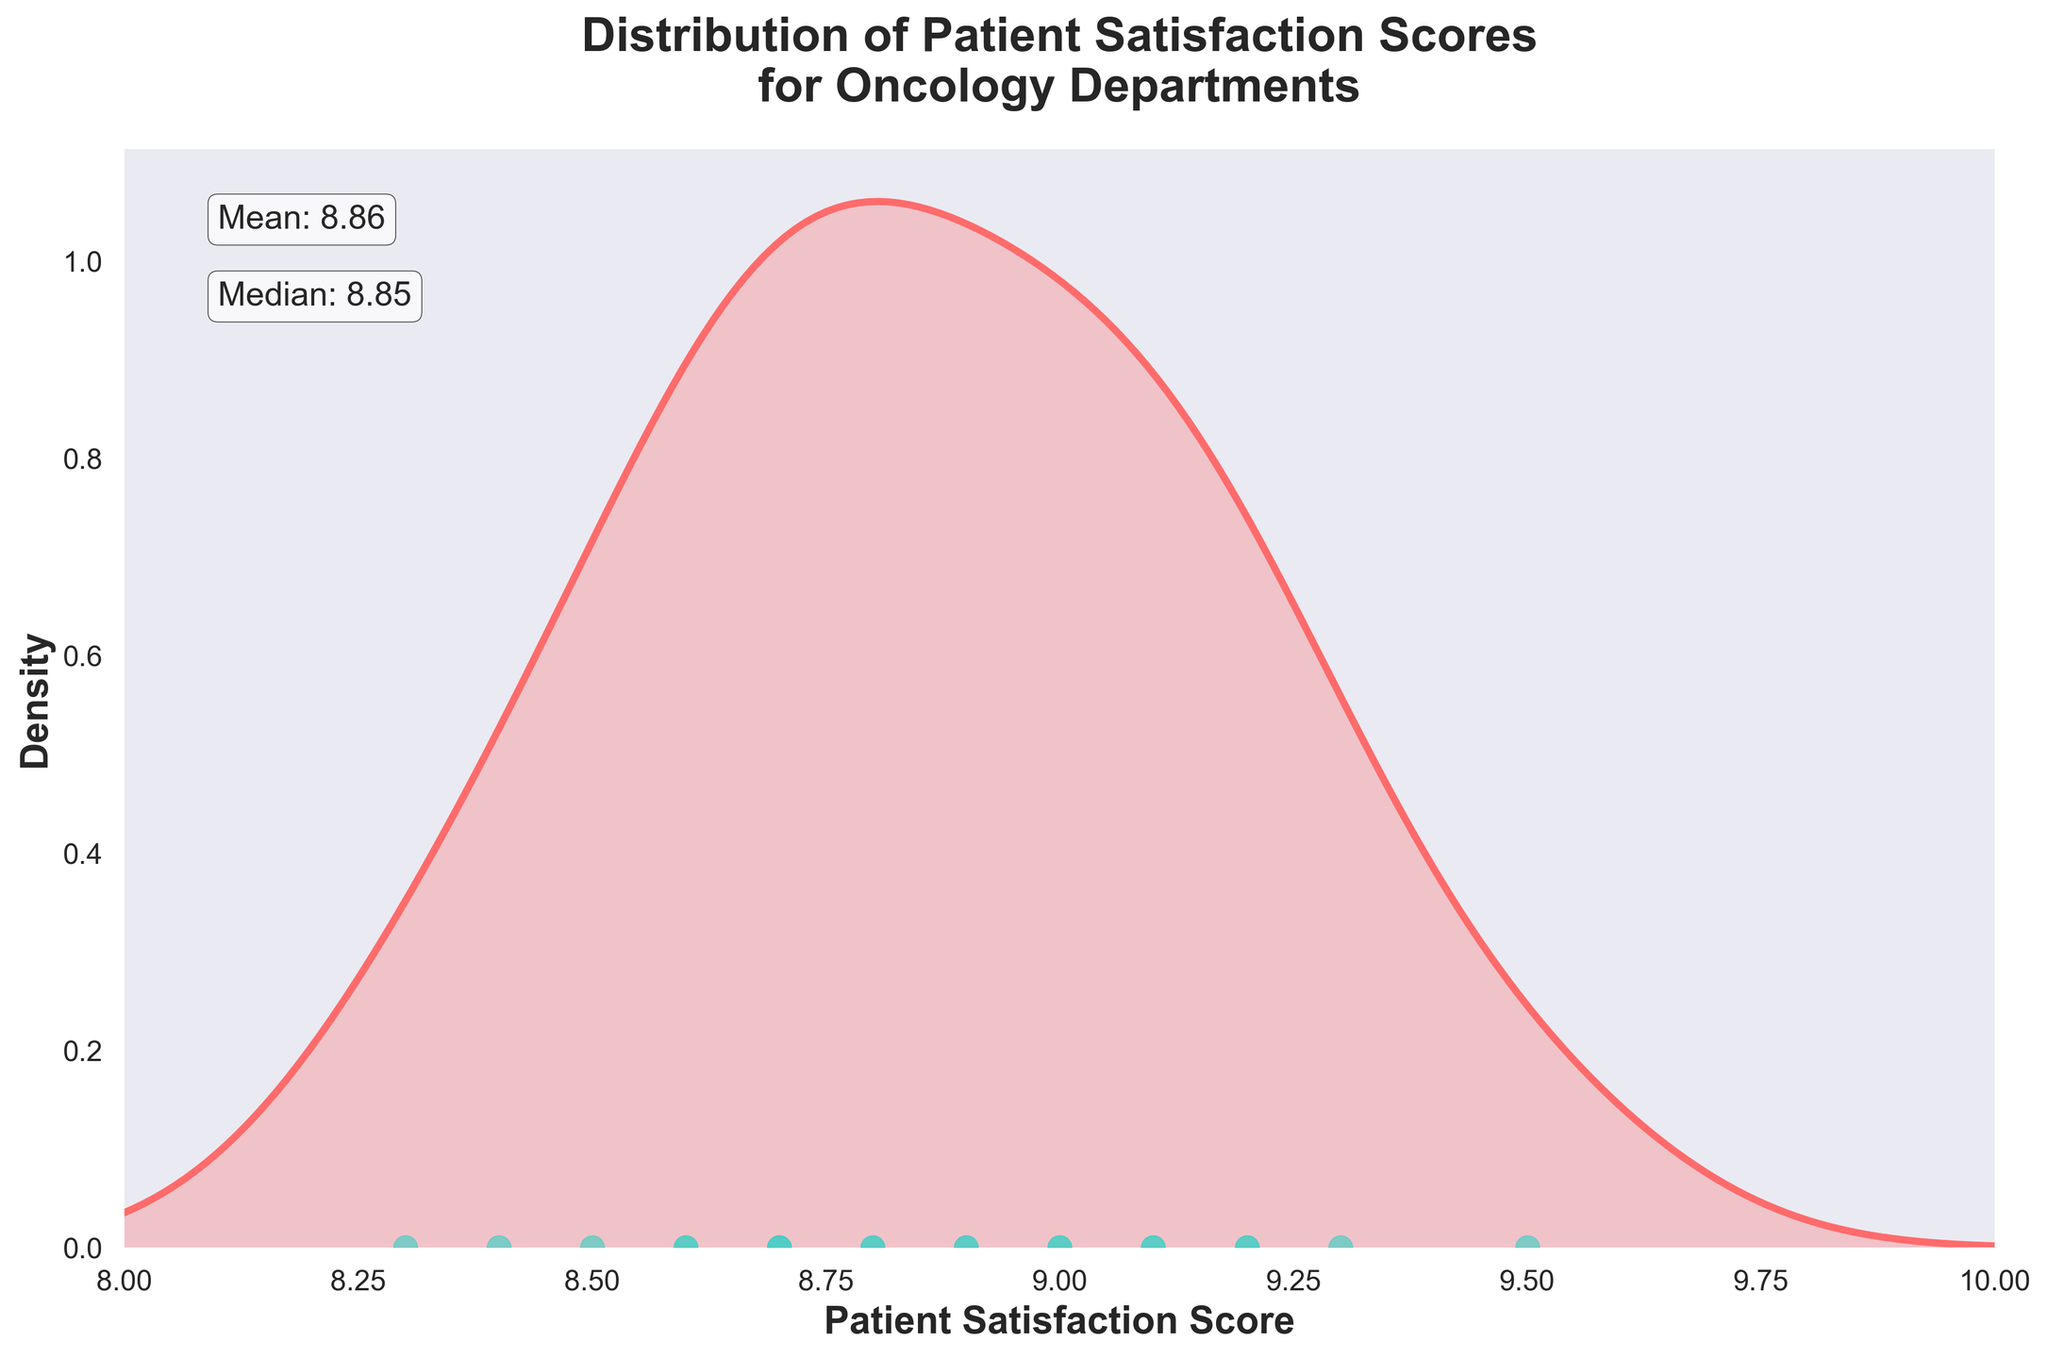How many hospitals have patient satisfaction scores plotted in the figure? There are individual data points in the plot, each representing a hospital. Counting these points will give the number of hospitals included.
Answer: 20 What is the mean patient satisfaction score? The mean score is provided on the plot as a text annotation. You can locate this information directly on the figure.
Answer: 8.91 What is the median patient satisfaction score? Similar to the mean, the median score is provided as a text annotation on the plot. You can locate this information directly on the figure.
Answer: 8.90 Which hospital has the highest patient satisfaction score? By looking at the scatter points on the x-axis and comparing their positions, the highest score will be the rightmost point. The corresponding hospital can be determined from the legend or data.
Answer: MD Anderson Cancer Center Is the distribution of patient satisfaction scores skewed, and if so, how? By observing the density curve, if it tails off more on one side, we can determine the skewness of the distribution (right or left).
Answer: Slightly right-skewed Which two hospitals have the closest patient satisfaction scores? The hospitals with the closest scores are represented by the closest scatter points on the x-axis. Identifying the two nearest points will reveal this.
Answer: New York-Presbyterian Hospital and Cleveland Clinic Is the patient satisfaction score for "Cedars-Sinai Medical Center" above or below the median score? By identifying Cedars-Sinai Medical Center's score and comparing it to the median score indicated on the plot, we can determine its relative position. Cedars-Sinai Medical Center has a score of 8.7, while the median score is 8.90.
Answer: Below What is the range of patient satisfaction scores? The range is calculated by subtracting the smallest score from the largest score. The smallest score visible on the plot is 8.3, and the largest is 9.5. Thus, the range is 9.5 - 8.3.
Answer: 1.2 How many hospitals have a patient satisfaction score above 9? Determine the number of scatter points located to the right of the 9 on the x-axis to find the number of hospitals with a score above this threshold.
Answer: 7 